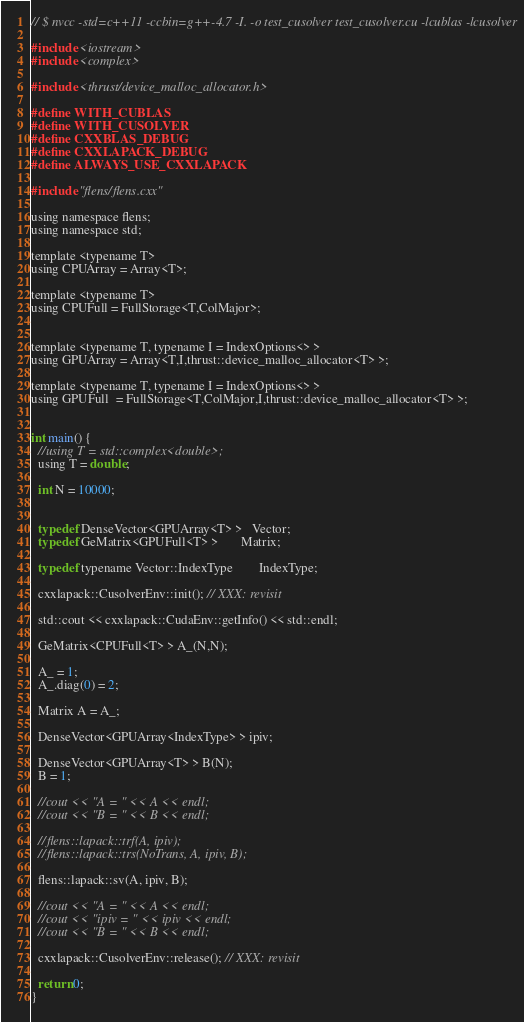<code> <loc_0><loc_0><loc_500><loc_500><_Cuda_>// $ nvcc -std=c++11 -ccbin=g++-4.7 -I. -o test_cusolver test_cusolver.cu -lcublas -lcusolver

#include <iostream>
#include <complex>

#include <thrust/device_malloc_allocator.h>

#define WITH_CUBLAS
#define WITH_CUSOLVER
#define CXXBLAS_DEBUG
#define CXXLAPACK_DEBUG
#define ALWAYS_USE_CXXLAPACK

#include "flens/flens.cxx"

using namespace flens;
using namespace std;

template <typename T>
using CPUArray = Array<T>;

template <typename T>
using CPUFull = FullStorage<T,ColMajor>;


template <typename T, typename I = IndexOptions<> >
using GPUArray = Array<T,I,thrust::device_malloc_allocator<T> >;

template <typename T, typename I = IndexOptions<> >
using GPUFull  = FullStorage<T,ColMajor,I,thrust::device_malloc_allocator<T> >;


int main() {
  //using T = std::complex<double>;
  using T = double;

  int N = 10000;


  typedef DenseVector<GPUArray<T> >   Vector;
  typedef GeMatrix<GPUFull<T> >       Matrix;

  typedef typename Vector::IndexType        IndexType;

  cxxlapack::CusolverEnv::init(); // XXX: revisit

  std::cout << cxxlapack::CudaEnv::getInfo() << std::endl;

  GeMatrix<CPUFull<T> > A_(N,N);

  A_ = 1;
  A_.diag(0) = 2;

  Matrix A = A_;

  DenseVector<GPUArray<IndexType> > ipiv;

  DenseVector<GPUArray<T> > B(N);
  B = 1;

  //cout << "A = " << A << endl;
  //cout << "B = " << B << endl;

  //flens::lapack::trf(A, ipiv);
  //flens::lapack::trs(NoTrans, A, ipiv, B);

  flens::lapack::sv(A, ipiv, B);

  //cout << "A = " << A << endl;
  //cout << "ipiv = " << ipiv << endl;
  //cout << "B = " << B << endl;

  cxxlapack::CusolverEnv::release(); // XXX: revisit

  return 0;
}
</code> 